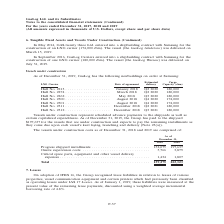From Gaslog's financial document, In which years was the vessels under construction costs recorded for? The document shows two values: 2018 and 2019. From the document: ") For the years ended December 31, 2017, 2018 and 2019 (All amounts expressed in thousands of U.S. Dollars, except share and per share data) Continued..." Also, What does vessels under construction represent? Scheduled advance payments to the shipyards as well as certain capitalized expenditures. The document states: "Vessels under construction represent scheduled advance payments to the shipyards as well as certain capitalized expenditures. As of December 31, 2019,..." Also, How much has the Group paid for the progress shipyard installments in 2019? According to the financial document, $197,637 (in thousands). The relevant text states: "ember 31, 2019, the Group has paid to the shipyard $197,637 for the vessels that are under construction and expects to pay the remaining installments as they co..." Additionally, Which year was the progress shipyard installments lower? According to the financial document, 2018. The relevant text states: "Continued) For the years ended December 31, 2017, 2018 and 2019 (All amounts expressed in thousands of U.S. Dollars, except share and per share data)..." Also, can you calculate: What was the change in onsite supervision costs  from 2018 to 2019 ? Based on the calculation: 3,879 - 5,766 , the result is -1887 (in thousands). This is based on the information: "152,075 197,637 Onsite supervision costs . 5,766 3,879 Critical spare parts, equipment and other vessel delivery expenses . 1,434 1,807 ents . 152,075 197,637 Onsite supervision costs . 5,766 3,879 Cr..." The key data points involved are: 3,879, 5,766. Also, can you calculate: What was the percentage change in total cost from 2018 to 2019? To answer this question, I need to perform calculations using the financial data. The calculation is: (203,323 - 159,275)/159,275 , which equals 27.66 (percentage). This is based on the information: "Total . 159,275 203,323 Total . 159,275 203,323..." The key data points involved are: 159,275, 203,323. 